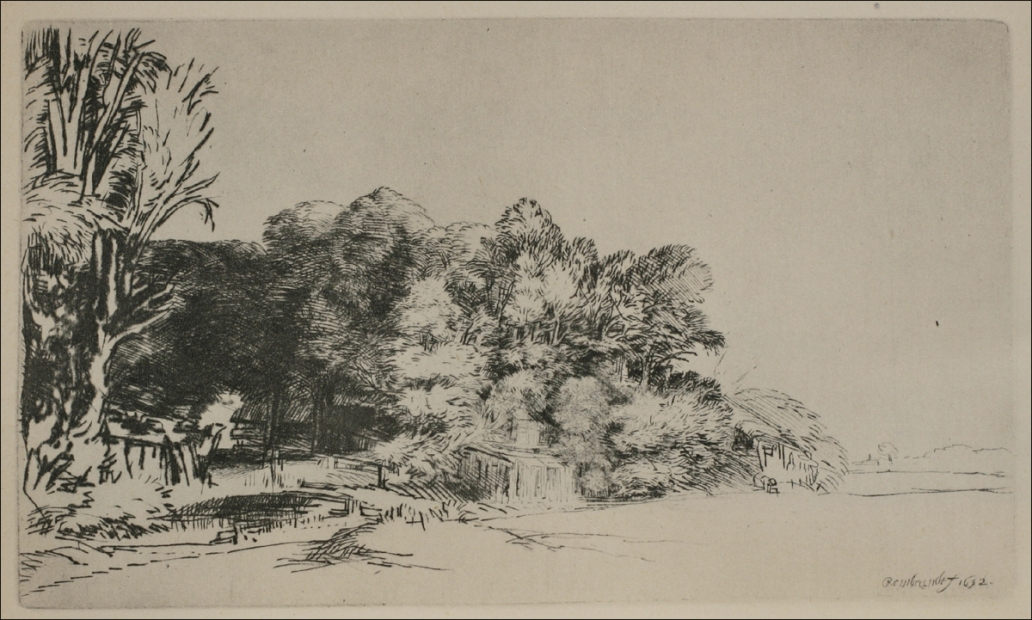What do you see happening in this image? The image presents a calming black and white etching of a pastoral landscape, likely captured in the midst of a tranquil day. Towering trees line the scenery, their branches etched with finesse to suggest a soft canopy overhead. A meandering path cuts through the center, flanked by a modest wooden fence that seems to guide onlookers towards the more distant elements of the composition, possibly a quaint village or farmstead. The buildings in the distance blend harmoniously with the natural world, speaking to a symbiotic relationship between nature and human habitation. The etching method gives a timeless quality to the piece, with the dense hatching and clear contrasts imparting texture and depth. It's a snapshot of nature's quiet moments, likely designed to evoke contemplation and a sense of peace. 